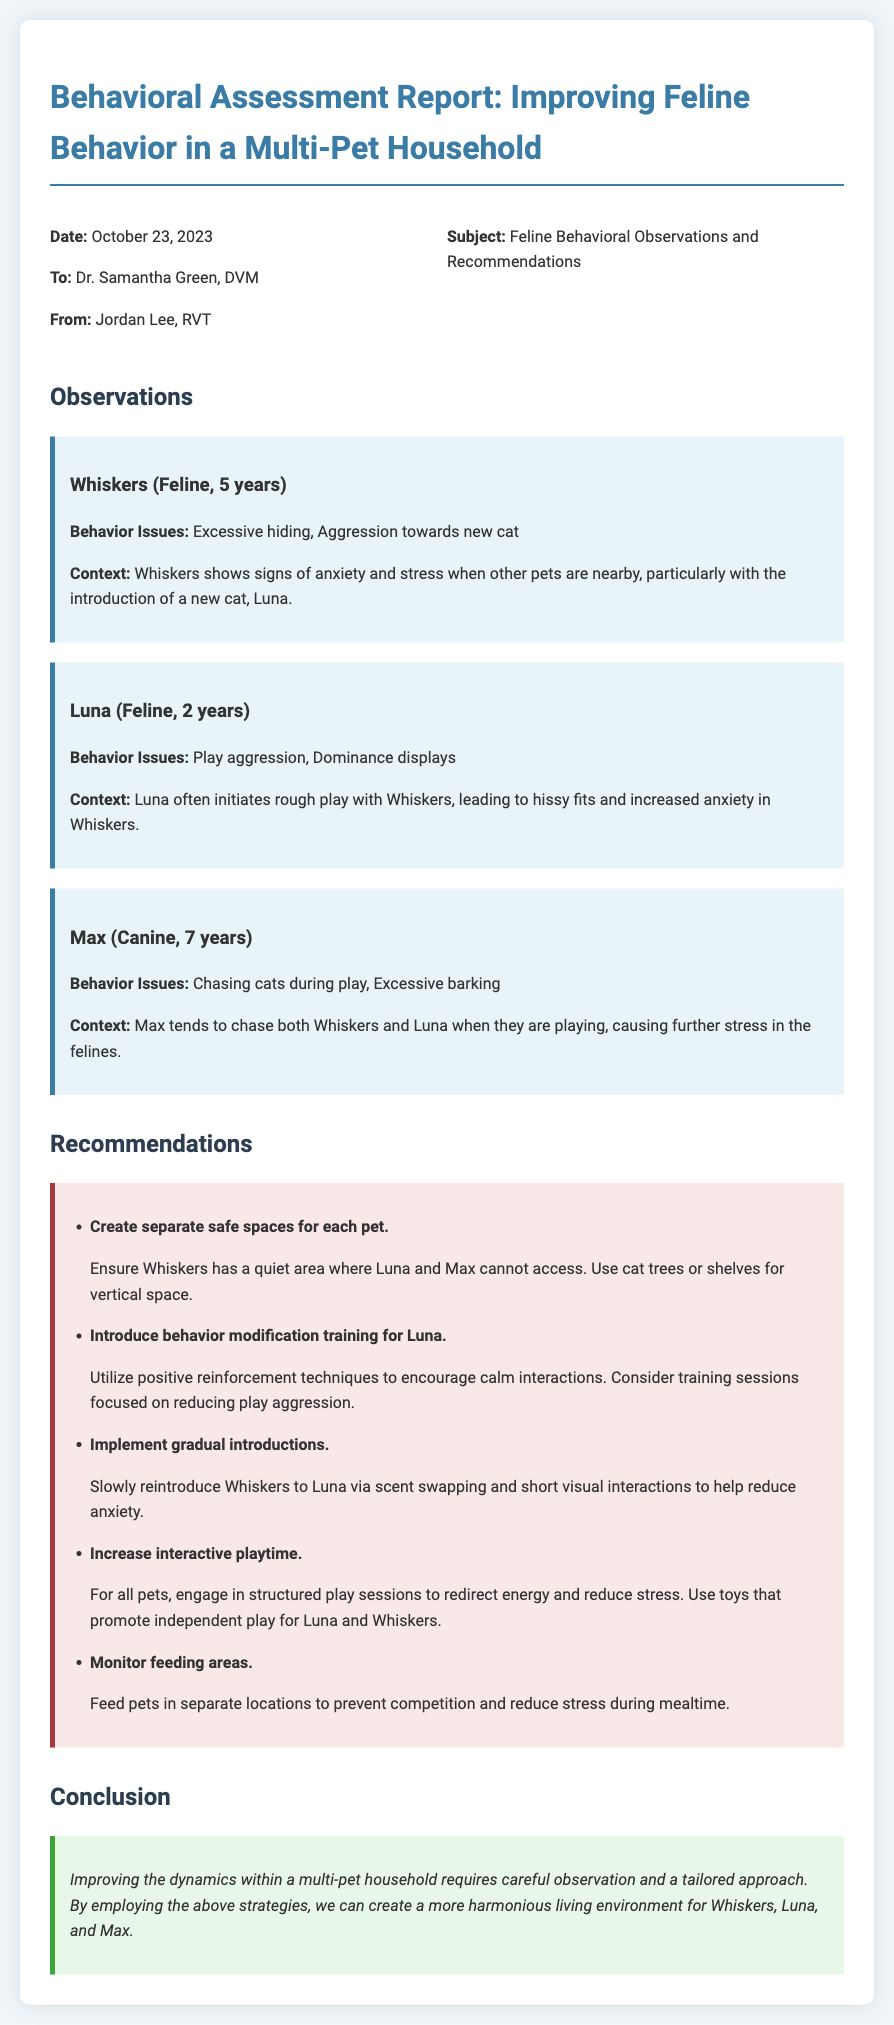What is the date of the report? The date of the report is mentioned at the beginning of the document.
Answer: October 23, 2023 Who is the veterinarian addressed in the memo? The memo specifies who it is addressed to in the header section.
Answer: Dr. Samantha Green, DVM How many pets are discussed in the report? The report outlines the observations for three pets specifically.
Answer: Three What behavior issue does Whiskers exhibit? The document lists specific behavior issues for each pet in the observations section.
Answer: Excessive hiding What recommendation involves introducing behavior modification training? The recommendations section specifies the behavior modification training for one of the pets.
Answer: Luna What is suggested to reduce stress during mealtime? The recommendations section provides specific strategies related to feeding.
Answer: Feed pets in separate locations What is the purpose of creating separate safe spaces? The document states the purpose in the recommendations section related to pet safety.
Answer: To ensure Whiskers has a quiet area How is playtime recommended to be increased? The recommendations suggest specific actions regarding interactive playtime for the pets.
Answer: Engage in structured play sessions 